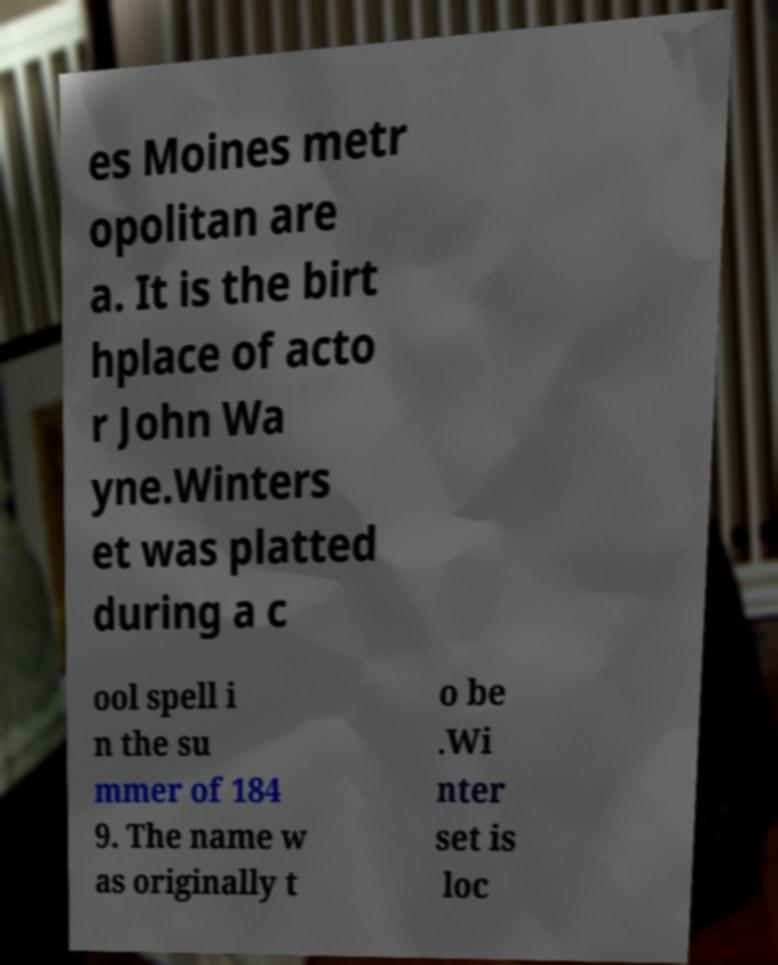Please identify and transcribe the text found in this image. es Moines metr opolitan are a. It is the birt hplace of acto r John Wa yne.Winters et was platted during a c ool spell i n the su mmer of 184 9. The name w as originally t o be .Wi nter set is loc 